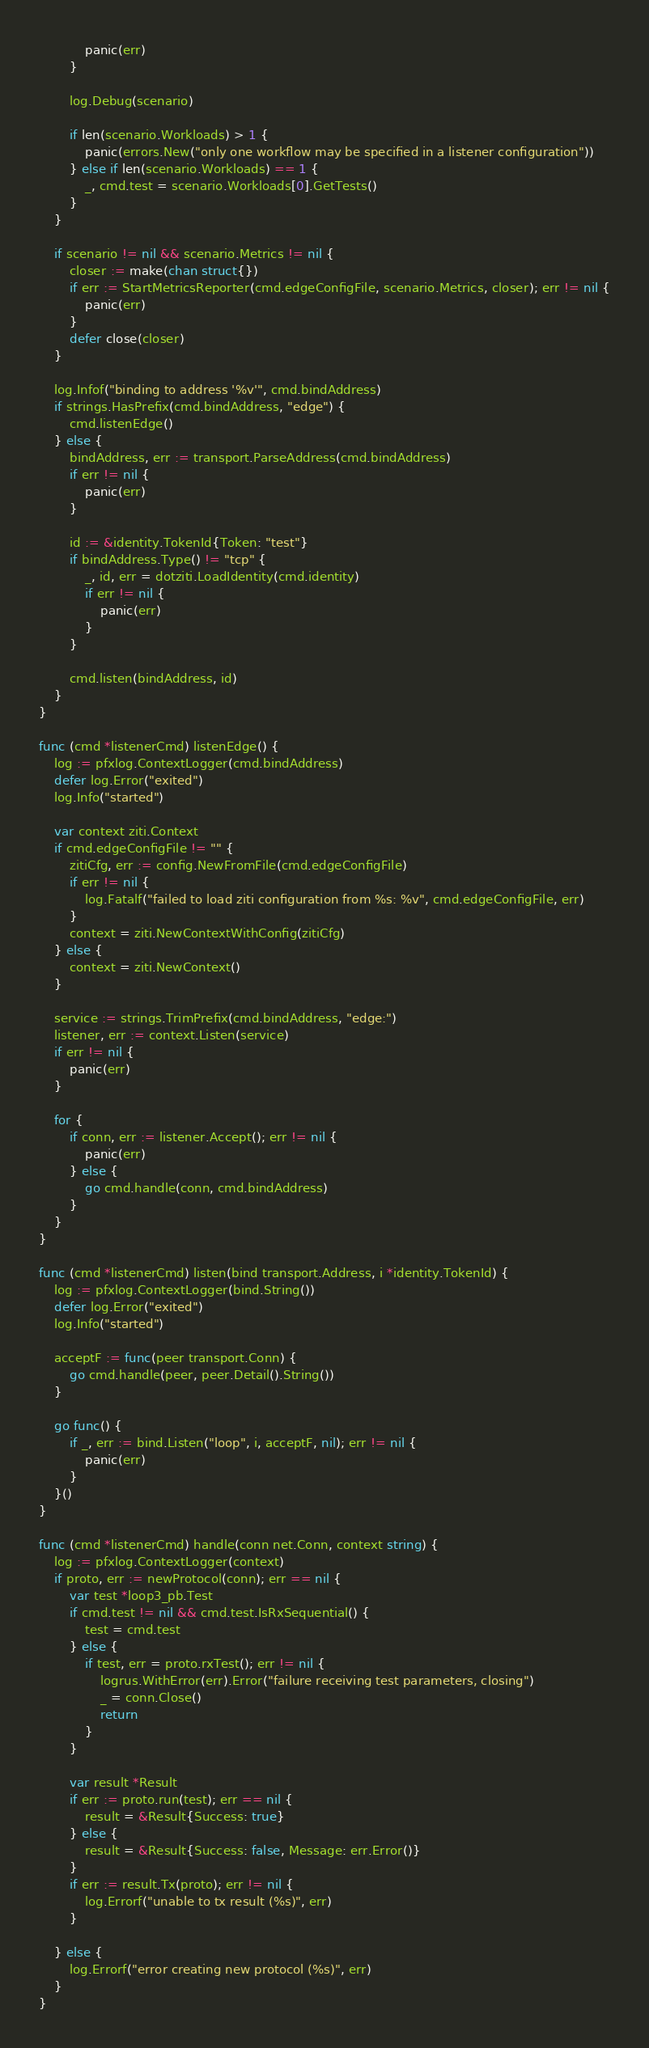Convert code to text. <code><loc_0><loc_0><loc_500><loc_500><_Go_>			panic(err)
		}

		log.Debug(scenario)

		if len(scenario.Workloads) > 1 {
			panic(errors.New("only one workflow may be specified in a listener configuration"))
		} else if len(scenario.Workloads) == 1 {
			_, cmd.test = scenario.Workloads[0].GetTests()
		}
	}

	if scenario != nil && scenario.Metrics != nil {
		closer := make(chan struct{})
		if err := StartMetricsReporter(cmd.edgeConfigFile, scenario.Metrics, closer); err != nil {
			panic(err)
		}
		defer close(closer)
	}

	log.Infof("binding to address '%v'", cmd.bindAddress)
	if strings.HasPrefix(cmd.bindAddress, "edge") {
		cmd.listenEdge()
	} else {
		bindAddress, err := transport.ParseAddress(cmd.bindAddress)
		if err != nil {
			panic(err)
		}

		id := &identity.TokenId{Token: "test"}
		if bindAddress.Type() != "tcp" {
			_, id, err = dotziti.LoadIdentity(cmd.identity)
			if err != nil {
				panic(err)
			}
		}

		cmd.listen(bindAddress, id)
	}
}

func (cmd *listenerCmd) listenEdge() {
	log := pfxlog.ContextLogger(cmd.bindAddress)
	defer log.Error("exited")
	log.Info("started")

	var context ziti.Context
	if cmd.edgeConfigFile != "" {
		zitiCfg, err := config.NewFromFile(cmd.edgeConfigFile)
		if err != nil {
			log.Fatalf("failed to load ziti configuration from %s: %v", cmd.edgeConfigFile, err)
		}
		context = ziti.NewContextWithConfig(zitiCfg)
	} else {
		context = ziti.NewContext()
	}

	service := strings.TrimPrefix(cmd.bindAddress, "edge:")
	listener, err := context.Listen(service)
	if err != nil {
		panic(err)
	}

	for {
		if conn, err := listener.Accept(); err != nil {
			panic(err)
		} else {
			go cmd.handle(conn, cmd.bindAddress)
		}
	}
}

func (cmd *listenerCmd) listen(bind transport.Address, i *identity.TokenId) {
	log := pfxlog.ContextLogger(bind.String())
	defer log.Error("exited")
	log.Info("started")

	acceptF := func(peer transport.Conn) {
		go cmd.handle(peer, peer.Detail().String())
	}

	go func() {
		if _, err := bind.Listen("loop", i, acceptF, nil); err != nil {
			panic(err)
		}
	}()
}

func (cmd *listenerCmd) handle(conn net.Conn, context string) {
	log := pfxlog.ContextLogger(context)
	if proto, err := newProtocol(conn); err == nil {
		var test *loop3_pb.Test
		if cmd.test != nil && cmd.test.IsRxSequential() {
			test = cmd.test
		} else {
			if test, err = proto.rxTest(); err != nil {
				logrus.WithError(err).Error("failure receiving test parameters, closing")
				_ = conn.Close()
				return
			}
		}

		var result *Result
		if err := proto.run(test); err == nil {
			result = &Result{Success: true}
		} else {
			result = &Result{Success: false, Message: err.Error()}
		}
		if err := result.Tx(proto); err != nil {
			log.Errorf("unable to tx result (%s)", err)
		}

	} else {
		log.Errorf("error creating new protocol (%s)", err)
	}
}
</code> 